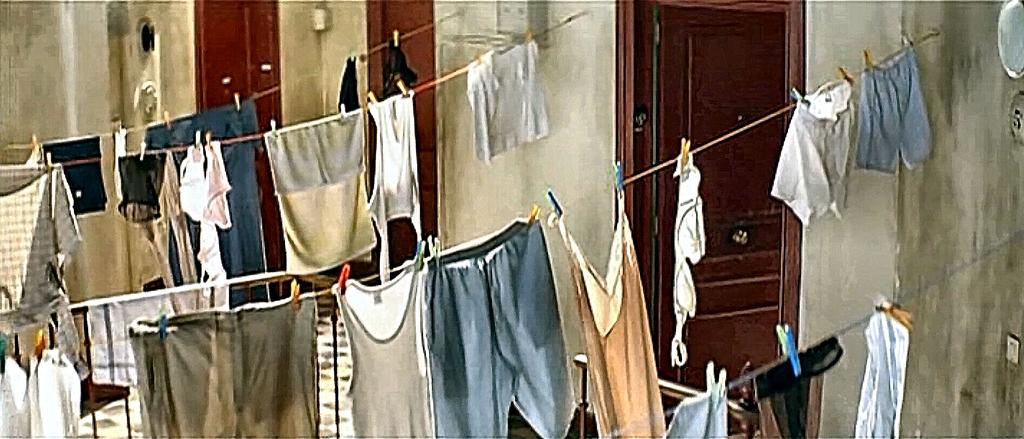What is attached to the wall in the image? There are ropes tied to the wall in the image. What are the ropes being used for? Clothes are being dried on the ropes. How many doors are visible on the right side of the image? There are three doors on the right side of the image. What separates each door? There is a wall between each door. Can you see any clouds in the image? There are no clouds visible in the image, as it focuses on ropes, clothes, doors, and walls. Is there a pest present in the image? There is no mention of a pest in the image, and no such creature is visible. 